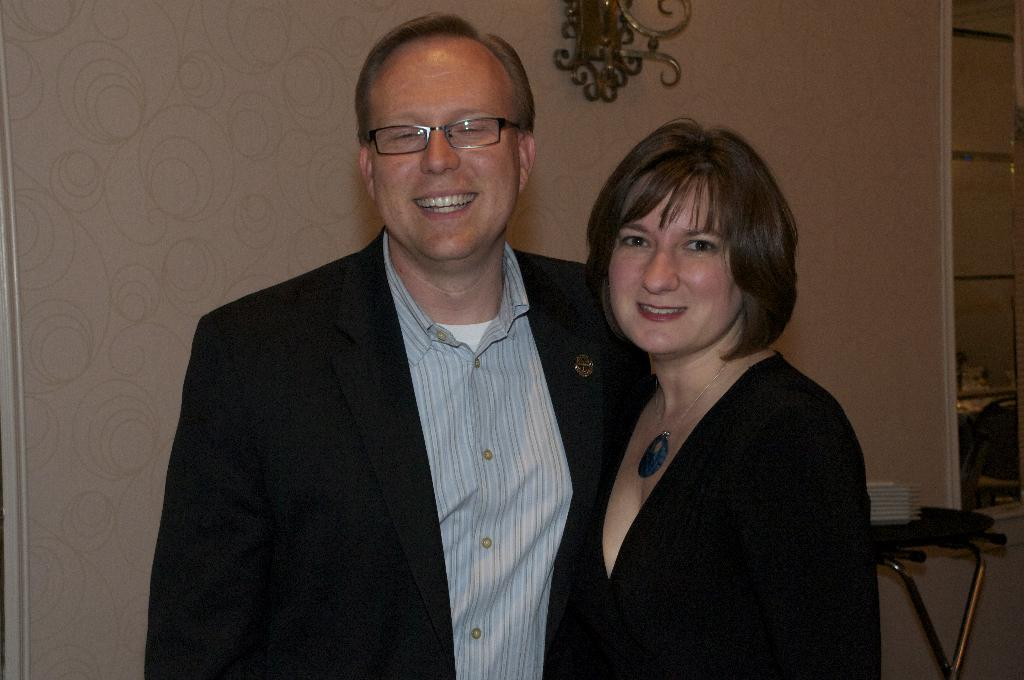How many people are in the image? There are two persons standing in the image. What is the facial expression of the persons in the image? The persons are smiling. What can be seen in the background of the image? There is a wall and a table visible in the background of the image. What is on the table in the image? There are plates on the table. What type of produce is being unloaded from the dock in the image? There is no dock or produce present in the image. What type of sofa can be seen in the image? There is no sofa present in the image. 